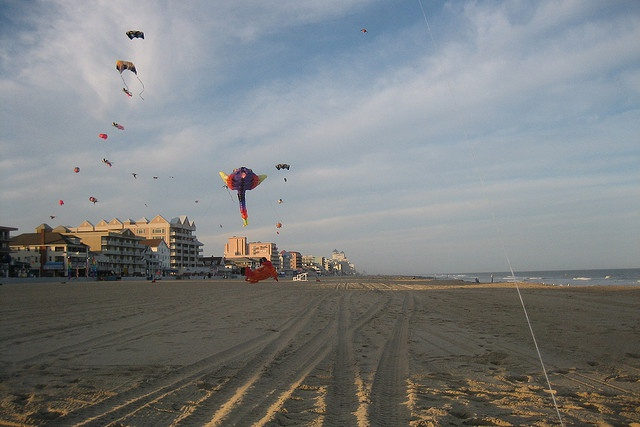Describe the objects in this image and their specific colors. I can see kite in gray, black, navy, and maroon tones, kite in gray, darkgray, maroon, and black tones, kite in gray, darkgray, and black tones, kite in gray, black, navy, and maroon tones, and kite in gray, darkgray, brown, and black tones in this image. 